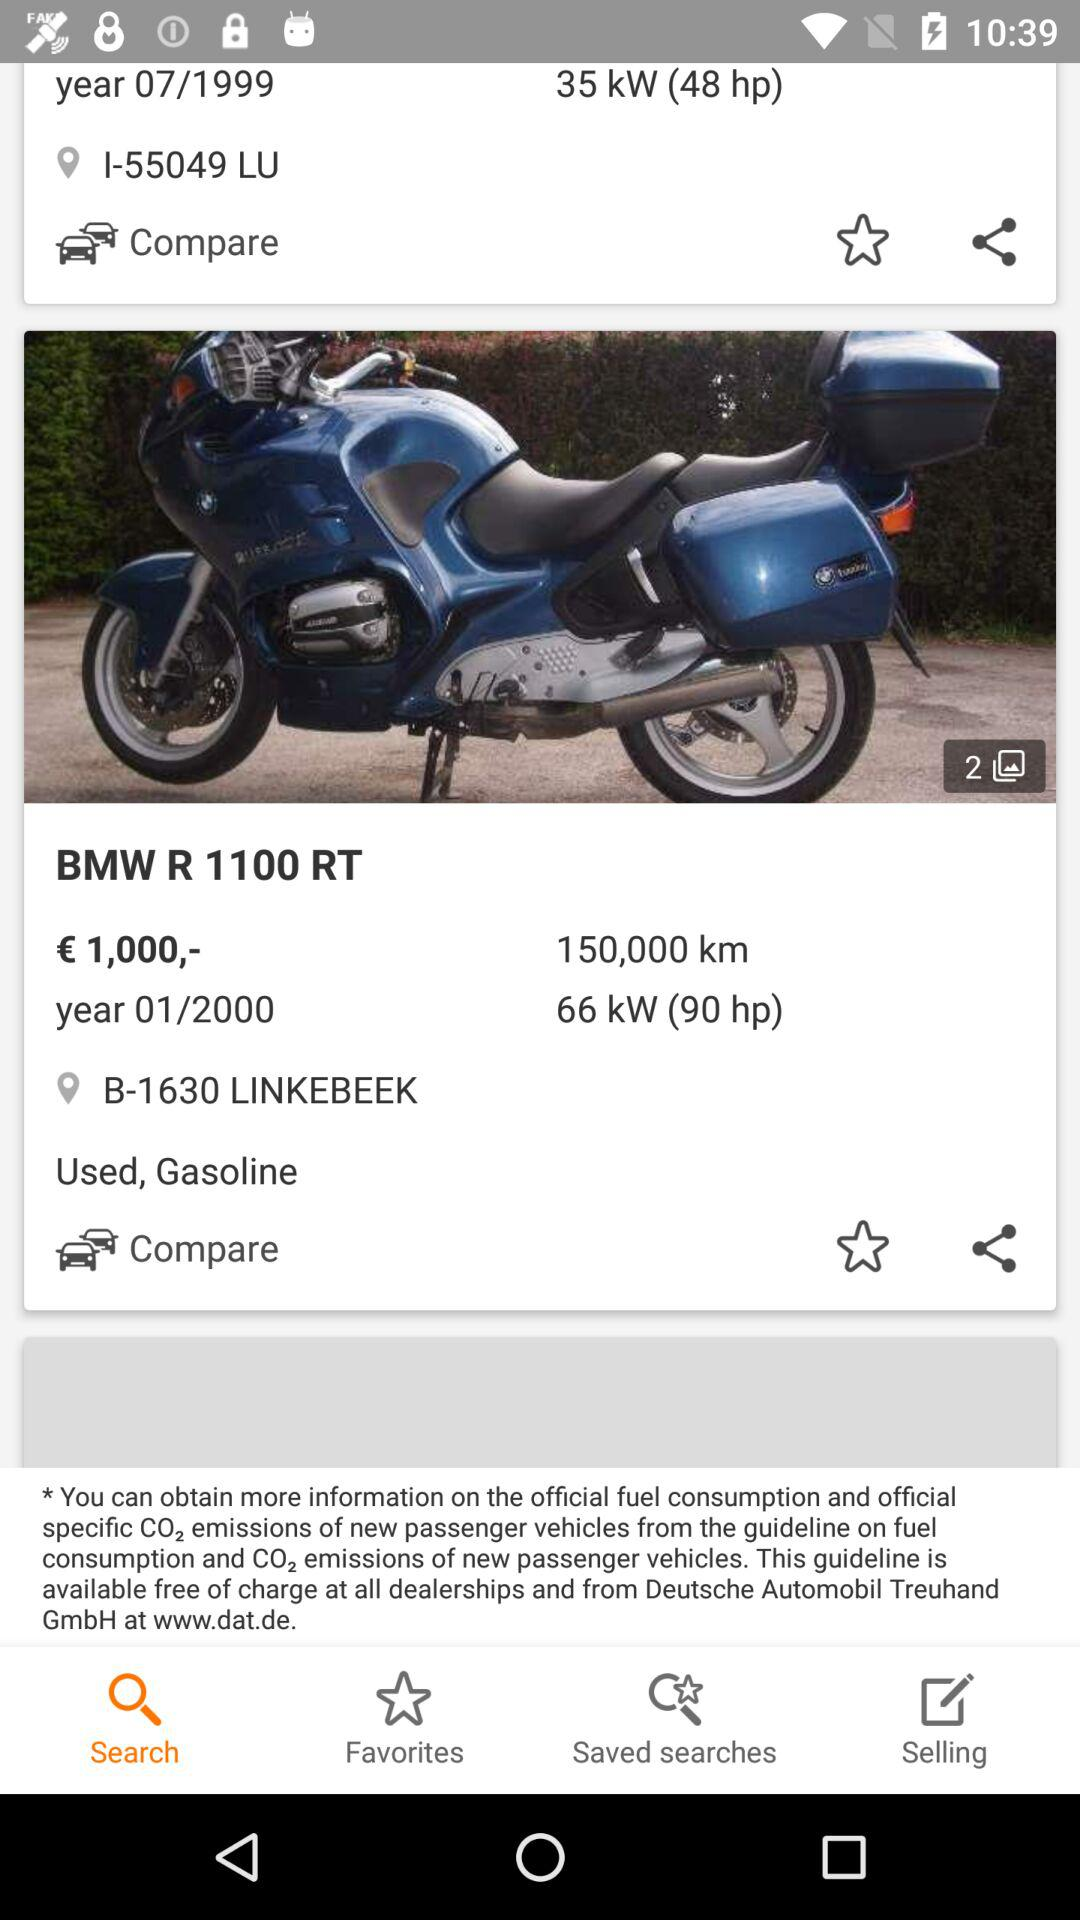Which tab is selected? The selected tab is "Search". 